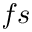<formula> <loc_0><loc_0><loc_500><loc_500>f s</formula> 